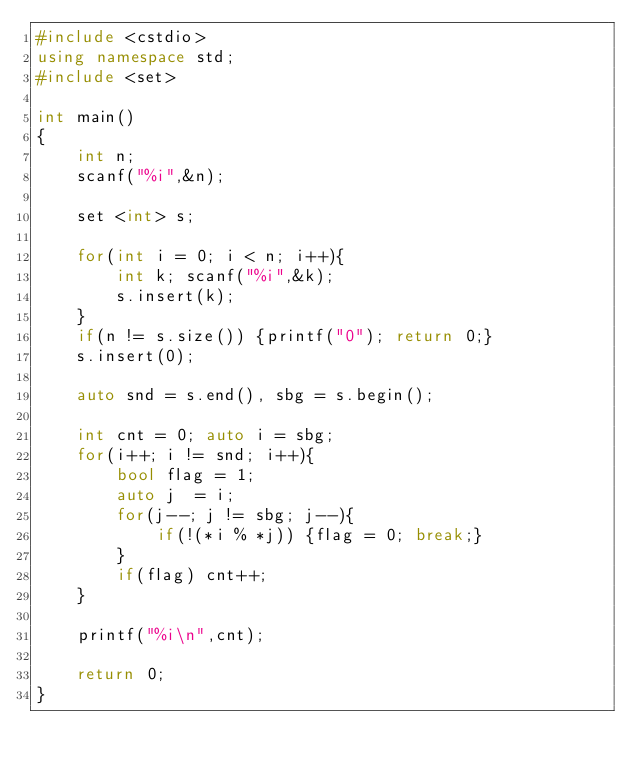Convert code to text. <code><loc_0><loc_0><loc_500><loc_500><_C++_>#include <cstdio>
using namespace std;
#include <set>

int main()
{
    int n;
    scanf("%i",&n);

    set <int> s;

    for(int i = 0; i < n; i++){
        int k; scanf("%i",&k);
        s.insert(k);
    }
    if(n != s.size()) {printf("0"); return 0;}
    s.insert(0);

    auto snd = s.end(), sbg = s.begin();

    int cnt = 0; auto i = sbg;
    for(i++; i != snd; i++){
        bool flag = 1;
        auto j  = i;
        for(j--; j != sbg; j--){
            if(!(*i % *j)) {flag = 0; break;}
        }
        if(flag) cnt++;
    }

    printf("%i\n",cnt);

    return 0;
}
</code> 